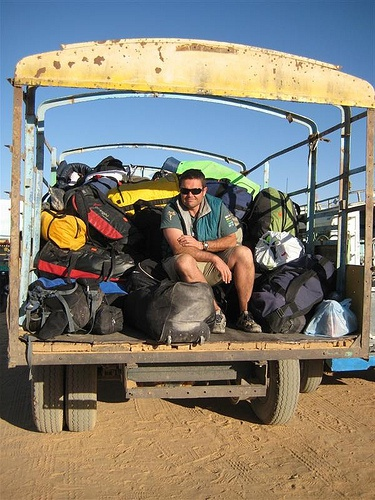Describe the objects in this image and their specific colors. I can see truck in gray, black, khaki, and tan tones, people in gray, black, salmon, and brown tones, suitcase in gray and black tones, suitcase in gray, black, and tan tones, and backpack in gray and black tones in this image. 